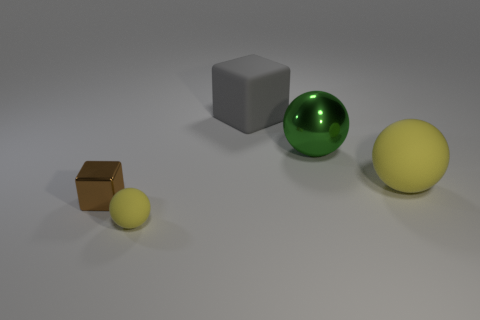Are there an equal number of green objects in front of the small matte thing and big gray matte blocks?
Offer a very short reply. No. Are there any green things to the left of the tiny matte ball?
Provide a succinct answer. No. There is a brown metallic object; is it the same shape as the large yellow thing behind the tiny rubber ball?
Provide a succinct answer. No. What color is the other small thing that is the same material as the green thing?
Keep it short and to the point. Brown. The large rubber ball has what color?
Give a very brief answer. Yellow. Is the green sphere made of the same material as the yellow sphere to the right of the tiny matte ball?
Give a very brief answer. No. What number of things are in front of the gray rubber block and to the left of the big green metal sphere?
Offer a very short reply. 2. The matte thing that is the same size as the brown block is what shape?
Give a very brief answer. Sphere. There is a rubber ball on the left side of the rubber object that is on the right side of the large gray rubber thing; is there a cube that is left of it?
Keep it short and to the point. Yes. There is a small matte ball; does it have the same color as the matte sphere that is on the right side of the small yellow ball?
Your answer should be compact. Yes. 